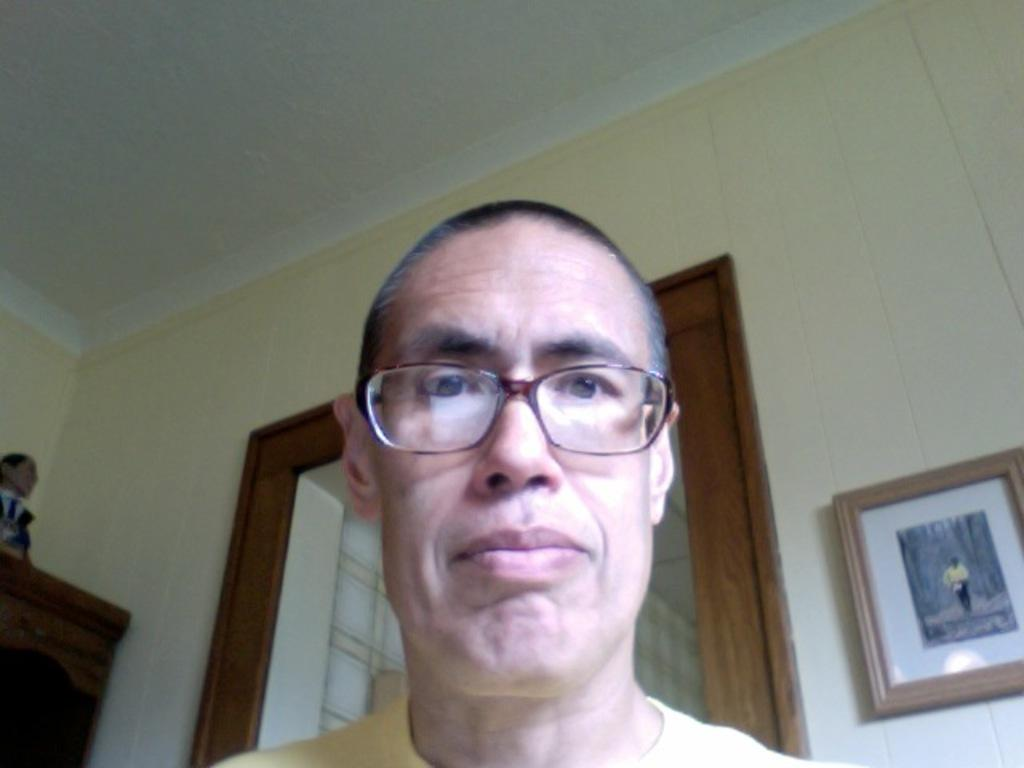Who is present in the image? There is a man in the image. What is the man wearing? The man is wearing spectacles. What can be seen on the wall in the image? There is a photo frame on the wall in the image. What object is on the table in the image? There is a toy on the table in the image. How many dimes are on the table next to the toy in the image? There is no mention of dimes in the image; only a toy is present on the table. 